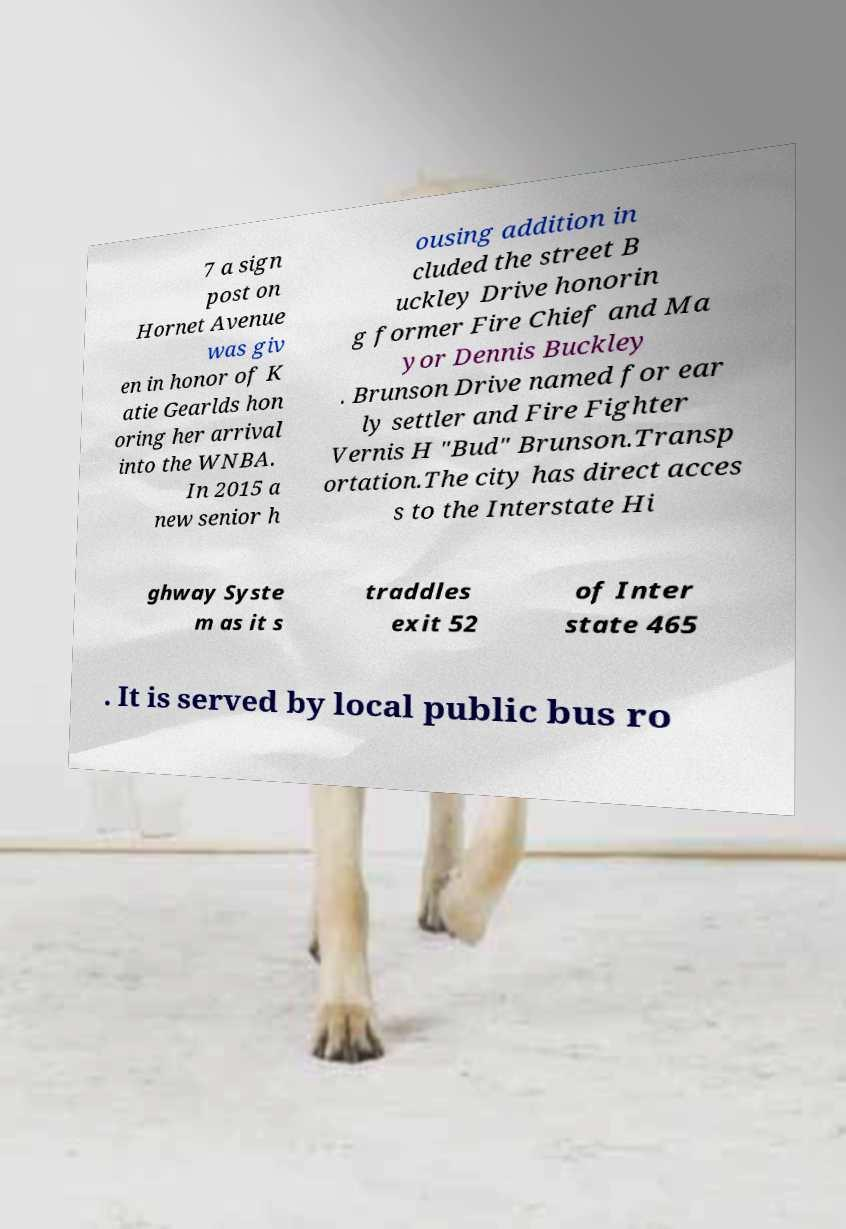Please identify and transcribe the text found in this image. 7 a sign post on Hornet Avenue was giv en in honor of K atie Gearlds hon oring her arrival into the WNBA. In 2015 a new senior h ousing addition in cluded the street B uckley Drive honorin g former Fire Chief and Ma yor Dennis Buckley . Brunson Drive named for ear ly settler and Fire Fighter Vernis H "Bud" Brunson.Transp ortation.The city has direct acces s to the Interstate Hi ghway Syste m as it s traddles exit 52 of Inter state 465 . It is served by local public bus ro 